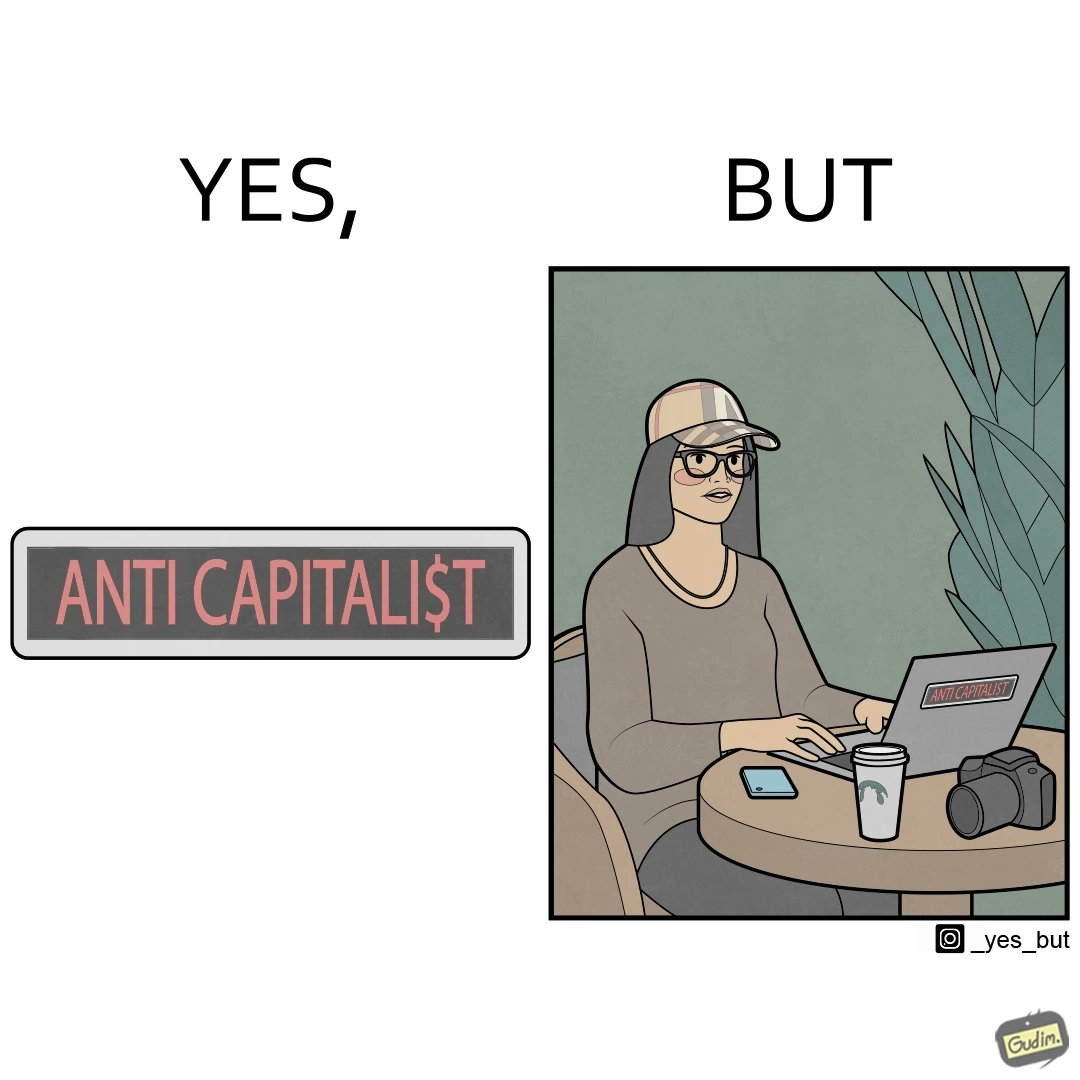What is shown in the left half versus the right half of this image? In the left part of the image: The image is just text with red font saying anti capitalist where the letter s in the capitalist is replaced with the dollar sign. In the right part of the image: A woman wearing glasses and a cap using laptop with the sign anti capitalist on it. The women has a phone, a camera and a cup on the table. She is working. 